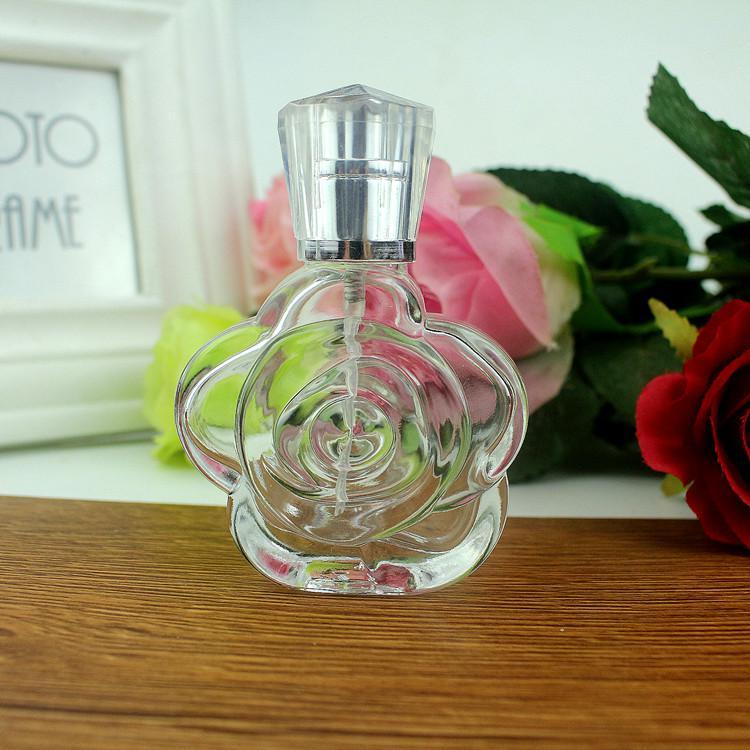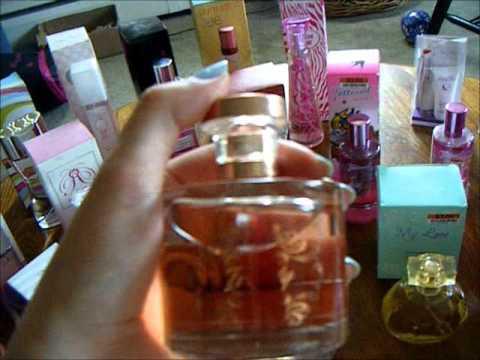The first image is the image on the left, the second image is the image on the right. Assess this claim about the two images: "A person is holding a product.". Correct or not? Answer yes or no. Yes. The first image is the image on the left, the second image is the image on the right. Given the left and right images, does the statement "The left image includes a horizontal row of at least five bottles of the same size and shape, but in different fragrance varieties." hold true? Answer yes or no. No. 